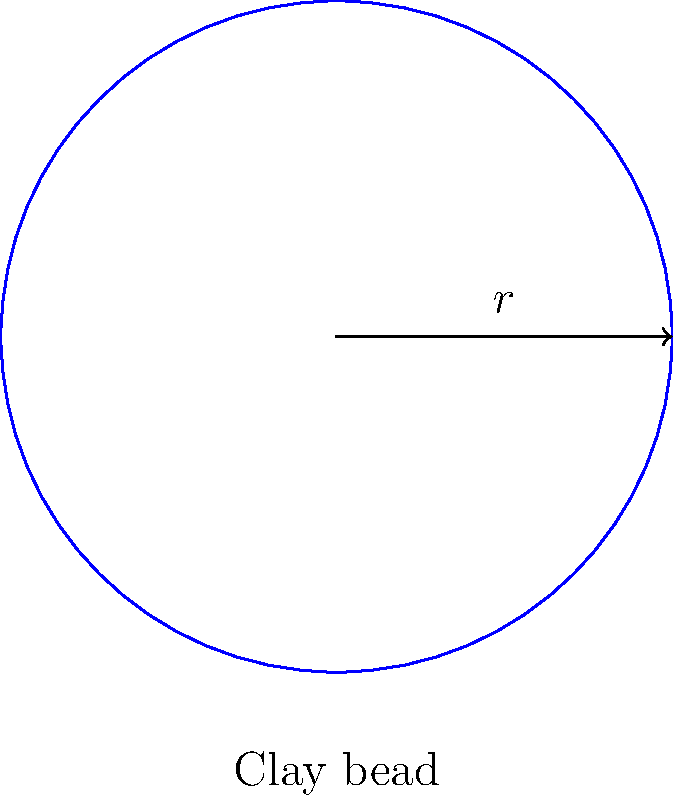In your excavation of an ancient African settlement, you discover a perfectly spherical clay bead used in jewelry making. The bead has a radius of 0.5 cm. Estimate the surface area of this bead, assuming it's a perfect sphere. Round your answer to the nearest square centimeter. To estimate the surface area of a spherical clay bead, we can use the formula for the surface area of a sphere:

$$A = 4\pi r^2$$

Where:
$A$ is the surface area
$r$ is the radius of the sphere

Given:
Radius $r = 0.5$ cm

Step 1: Substitute the radius into the formula:
$$A = 4\pi (0.5)^2$$

Step 2: Calculate the squared radius:
$$A = 4\pi (0.25)$$

Step 3: Multiply:
$$A = \pi$$

Step 4: Calculate the approximate value (π ≈ 3.14159):
$$A ≈ 3.14159$$

Step 5: Round to the nearest square centimeter:
$$A ≈ 3 \text{ cm}^2$$

Therefore, the estimated surface area of the spherical clay bead is approximately 3 square centimeters.
Answer: $3 \text{ cm}^2$ 